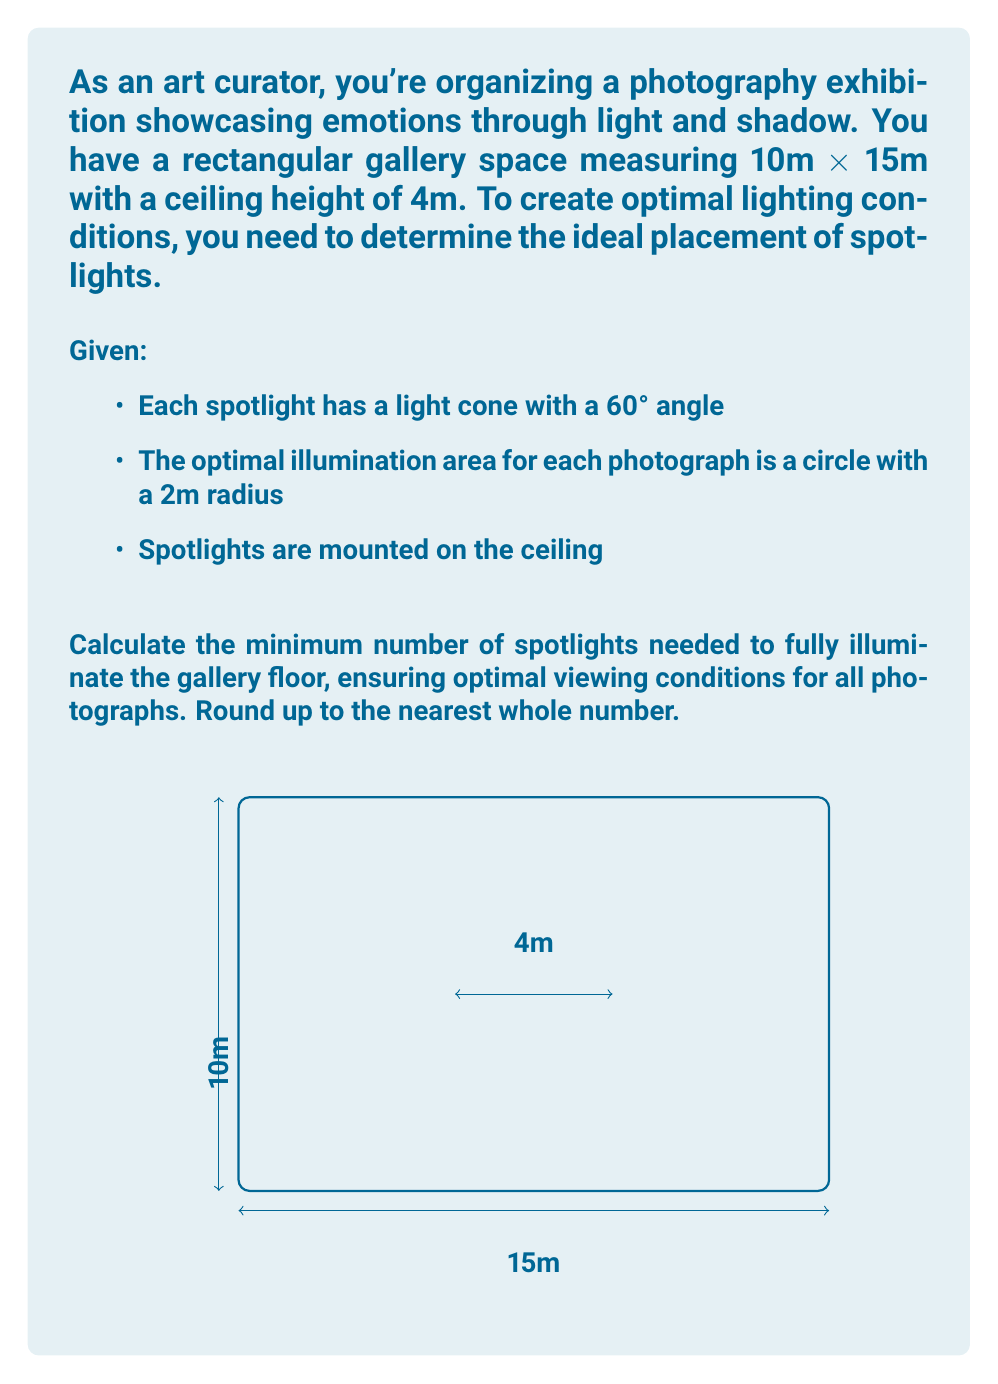Show me your answer to this math problem. Let's approach this step-by-step:

1) First, we need to calculate the radius of the light cone on the floor:
   $$\tan(30°) = \frac{\text{radius}}{\text{height}}$$
   $$\text{radius} = 4m \times \tan(30°) = 4m \times \frac{\sqrt{3}}{3} \approx 2.31m$$

2) The area illuminated by one spotlight is:
   $$A_{\text{spotlight}} = \pi r^2 = \pi \times (2.31m)^2 \approx 16.76m^2$$

3) The total area of the gallery is:
   $$A_{\text{gallery}} = 10m \times 15m = 150m^2$$

4) The number of spotlights needed is:
   $$n = \frac{A_{\text{gallery}}}{A_{\text{spotlight}}} = \frac{150m^2}{16.76m^2} \approx 8.95$$

5) Rounding up, we get 9 spotlights.

6) To verify if this is sufficient for optimal viewing:
   - Each photograph needs a 2m radius circle
   - Area of this circle: $\pi \times (2m)^2 = 12.57m^2$
   - Our spotlight illuminates $16.76m^2$, which is larger than required

Therefore, 9 spotlights will provide sufficient and optimal illumination for the photographs.
Answer: 9 spotlights 